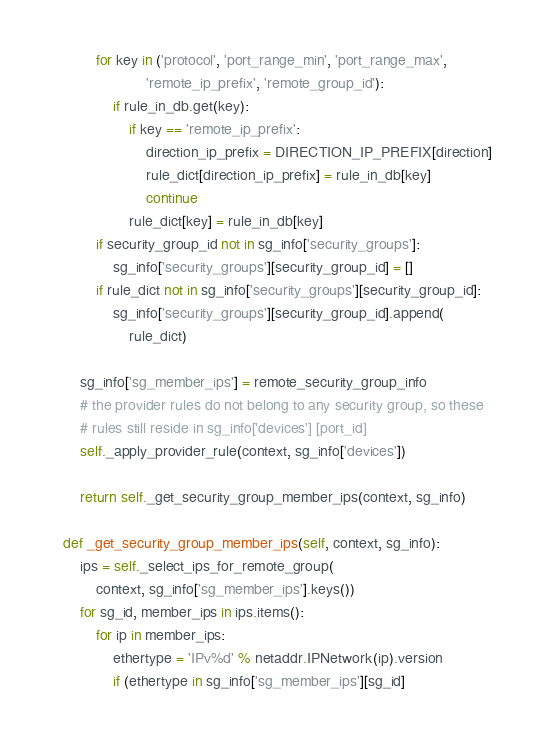Convert code to text. <code><loc_0><loc_0><loc_500><loc_500><_Python_>
            for key in ('protocol', 'port_range_min', 'port_range_max',
                        'remote_ip_prefix', 'remote_group_id'):
                if rule_in_db.get(key):
                    if key == 'remote_ip_prefix':
                        direction_ip_prefix = DIRECTION_IP_PREFIX[direction]
                        rule_dict[direction_ip_prefix] = rule_in_db[key]
                        continue
                    rule_dict[key] = rule_in_db[key]
            if security_group_id not in sg_info['security_groups']:
                sg_info['security_groups'][security_group_id] = []
            if rule_dict not in sg_info['security_groups'][security_group_id]:
                sg_info['security_groups'][security_group_id].append(
                    rule_dict)

        sg_info['sg_member_ips'] = remote_security_group_info
        # the provider rules do not belong to any security group, so these
        # rules still reside in sg_info['devices'] [port_id]
        self._apply_provider_rule(context, sg_info['devices'])

        return self._get_security_group_member_ips(context, sg_info)

    def _get_security_group_member_ips(self, context, sg_info):
        ips = self._select_ips_for_remote_group(
            context, sg_info['sg_member_ips'].keys())
        for sg_id, member_ips in ips.items():
            for ip in member_ips:
                ethertype = 'IPv%d' % netaddr.IPNetwork(ip).version
                if (ethertype in sg_info['sg_member_ips'][sg_id]</code> 